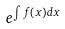Convert formula to latex. <formula><loc_0><loc_0><loc_500><loc_500>e ^ { \int f ( x ) d x }</formula> 